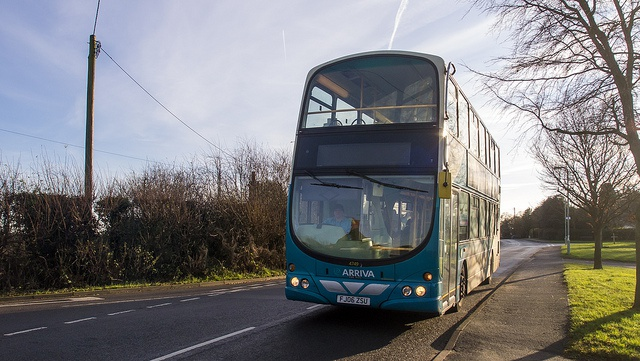Describe the objects in this image and their specific colors. I can see bus in darkgray, gray, black, darkblue, and blue tones, people in darkgray, gray, darkblue, and black tones, and people in darkgray, gray, and lightgray tones in this image. 